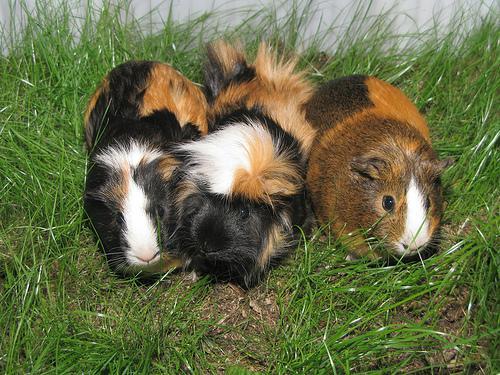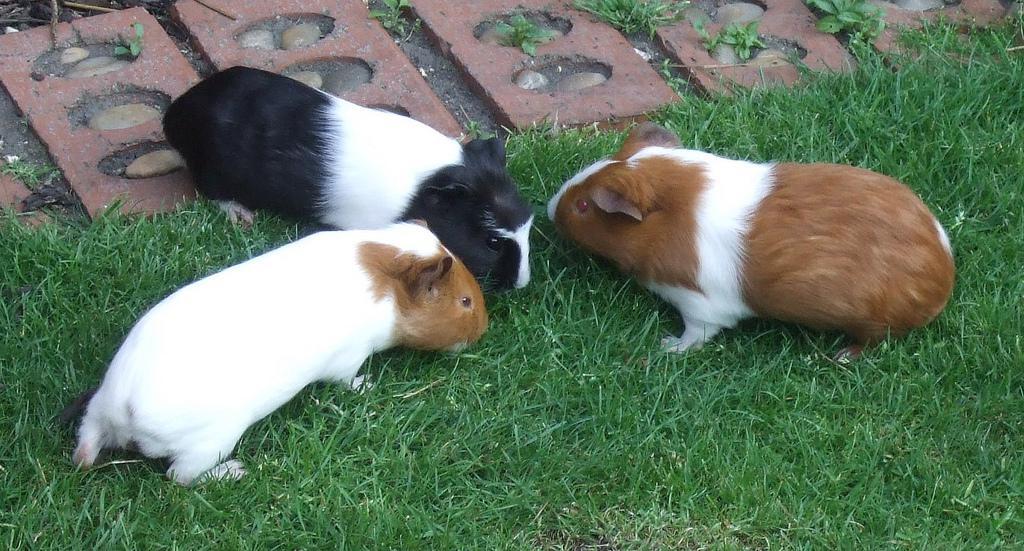The first image is the image on the left, the second image is the image on the right. Evaluate the accuracy of this statement regarding the images: "An image shows three multicolor guinea pigs posed side-by-side outdoors with greenery in the picture.". Is it true? Answer yes or no. Yes. The first image is the image on the left, the second image is the image on the right. For the images displayed, is the sentence "There are 6 guinea pigs in all, the three in the image on the right are lined up side by side, looking at the camera." factually correct? Answer yes or no. No. 